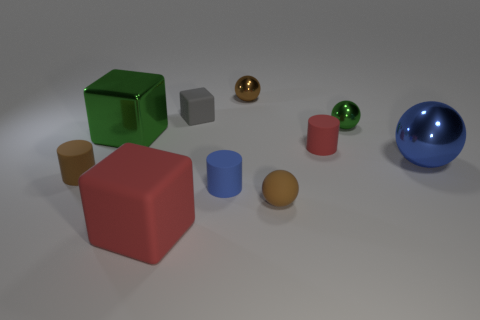What size is the red object that is in front of the large metal ball?
Offer a very short reply. Large. Is the number of green shiny objects to the right of the big red object greater than the number of small blue metallic balls?
Keep it short and to the point. Yes. The blue matte thing is what shape?
Your answer should be very brief. Cylinder. Does the small cylinder on the right side of the brown rubber sphere have the same color as the matte block that is on the left side of the gray matte thing?
Provide a short and direct response. Yes. Is the shape of the big green metal object the same as the brown metal object?
Provide a short and direct response. No. Is the material of the cube that is behind the large green metallic object the same as the small green ball?
Give a very brief answer. No. What shape is the thing that is on the left side of the brown shiny ball and behind the green cube?
Make the answer very short. Cube. There is a small object left of the big red matte block; are there any blue matte objects that are in front of it?
Make the answer very short. Yes. What number of other things are there of the same material as the big red thing
Offer a very short reply. 5. Does the tiny brown rubber thing to the left of the big rubber thing have the same shape as the red matte object to the right of the gray block?
Provide a succinct answer. Yes. 